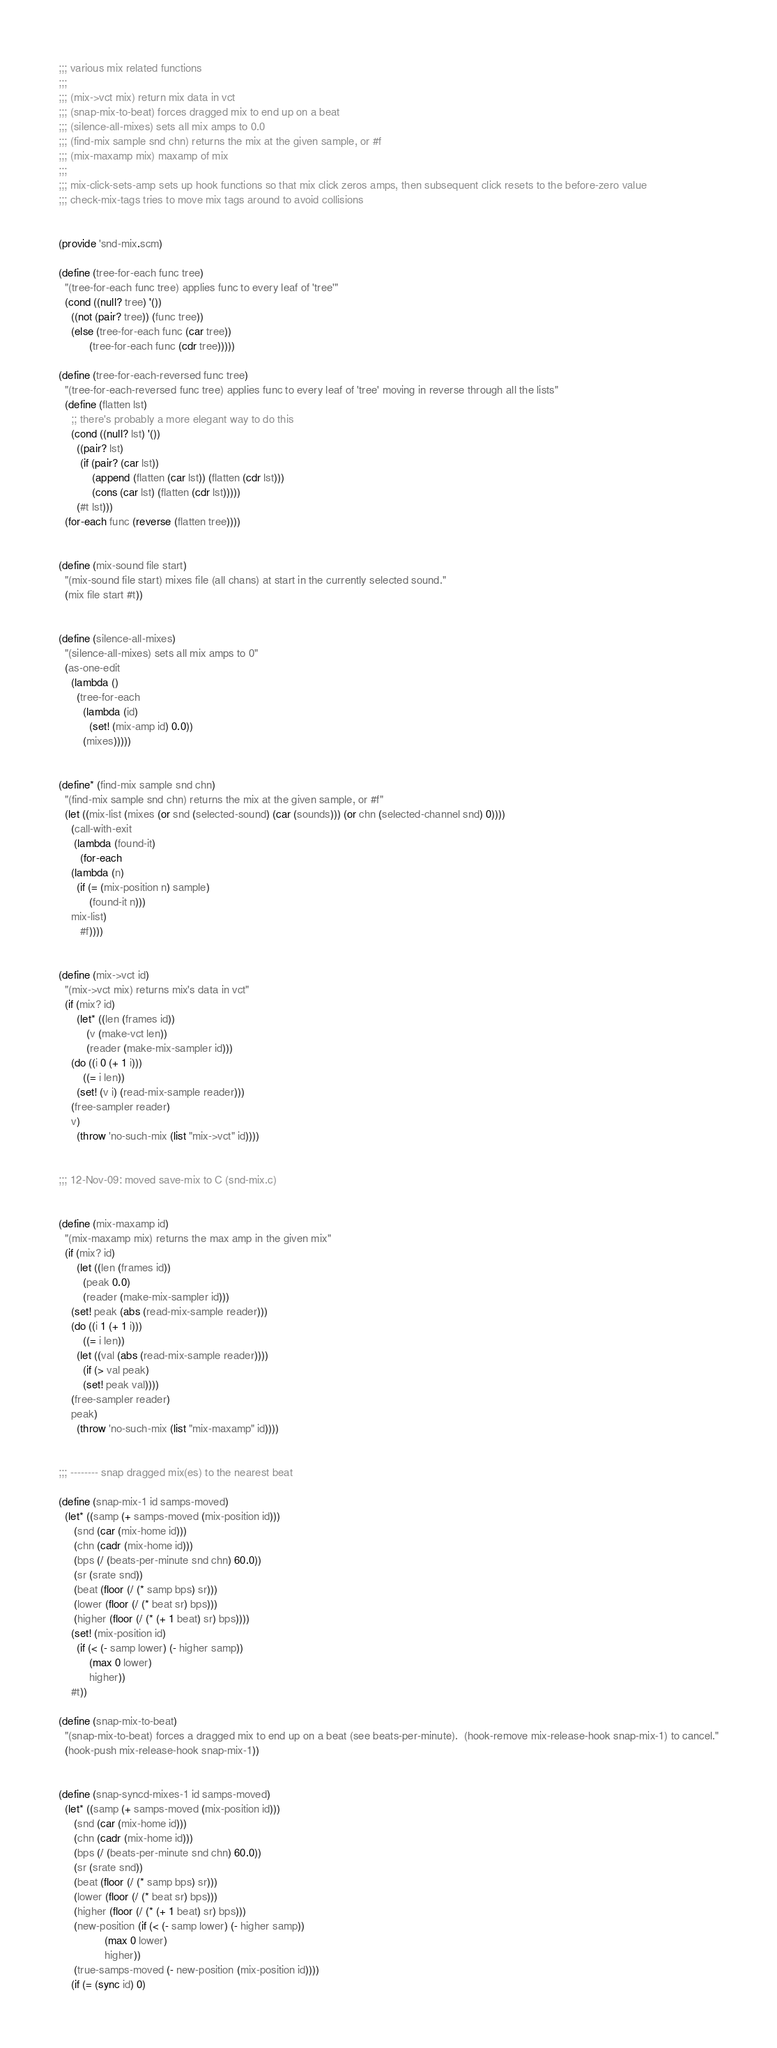Convert code to text. <code><loc_0><loc_0><loc_500><loc_500><_Scheme_>;;; various mix related functions
;;;
;;; (mix->vct mix) return mix data in vct
;;; (snap-mix-to-beat) forces dragged mix to end up on a beat
;;; (silence-all-mixes) sets all mix amps to 0.0
;;; (find-mix sample snd chn) returns the mix at the given sample, or #f
;;; (mix-maxamp mix) maxamp of mix
;;;
;;; mix-click-sets-amp sets up hook functions so that mix click zeros amps, then subsequent click resets to the before-zero value
;;; check-mix-tags tries to move mix tags around to avoid collisions


(provide 'snd-mix.scm)

(define (tree-for-each func tree)
  "(tree-for-each func tree) applies func to every leaf of 'tree'"
  (cond ((null? tree) '())
	((not (pair? tree)) (func tree))
	(else (tree-for-each func (car tree))
	      (tree-for-each func (cdr tree)))))

(define (tree-for-each-reversed func tree)
  "(tree-for-each-reversed func tree) applies func to every leaf of 'tree' moving in reverse through all the lists"
  (define (flatten lst)
    ;; there's probably a more elegant way to do this
    (cond ((null? lst) '())
	  ((pair? lst)
	   (if (pair? (car lst))
	       (append (flatten (car lst)) (flatten (cdr lst)))
	       (cons (car lst) (flatten (cdr lst)))))
	  (#t lst)))
  (for-each func (reverse (flatten tree))))


(define (mix-sound file start)
  "(mix-sound file start) mixes file (all chans) at start in the currently selected sound."
  (mix file start #t))


(define (silence-all-mixes)
  "(silence-all-mixes) sets all mix amps to 0"
  (as-one-edit
    (lambda ()
      (tree-for-each
        (lambda (id)
          (set! (mix-amp id) 0.0))
        (mixes)))))


(define* (find-mix sample snd chn)
  "(find-mix sample snd chn) returns the mix at the given sample, or #f"
  (let ((mix-list (mixes (or snd (selected-sound) (car (sounds))) (or chn (selected-channel snd) 0))))
    (call-with-exit
     (lambda (found-it)
       (for-each
	(lambda (n)
	  (if (= (mix-position n) sample)
	      (found-it n)))
	mix-list)
       #f))))


(define (mix->vct id)
  "(mix->vct mix) returns mix's data in vct"
  (if (mix? id)
      (let* ((len (frames id))
	     (v (make-vct len))
	     (reader (make-mix-sampler id)))
	(do ((i 0 (+ 1 i)))
	    ((= i len))
	  (set! (v i) (read-mix-sample reader)))
	(free-sampler reader)
	v)
      (throw 'no-such-mix (list "mix->vct" id))))


;;; 12-Nov-09: moved save-mix to C (snd-mix.c)


(define (mix-maxamp id)
  "(mix-maxamp mix) returns the max amp in the given mix"
  (if (mix? id)
      (let ((len (frames id))
	    (peak 0.0)
	    (reader (make-mix-sampler id)))
	(set! peak (abs (read-mix-sample reader)))
	(do ((i 1 (+ 1 i)))
	    ((= i len))
	  (let ((val (abs (read-mix-sample reader))))
	    (if (> val peak)
		(set! peak val))))
	(free-sampler reader)
	peak)
      (throw 'no-such-mix (list "mix-maxamp" id))))
	  

;;; -------- snap dragged mix(es) to the nearest beat

(define (snap-mix-1 id samps-moved)
  (let* ((samp (+ samps-moved (mix-position id)))
	 (snd (car (mix-home id)))
	 (chn (cadr (mix-home id)))
	 (bps (/ (beats-per-minute snd chn) 60.0))
	 (sr (srate snd))
	 (beat (floor (/ (* samp bps) sr)))
	 (lower (floor (/ (* beat sr) bps)))
	 (higher (floor (/ (* (+ 1 beat) sr) bps))))
    (set! (mix-position id)
	  (if (< (- samp lower) (- higher samp))
	      (max 0 lower)
	      higher))
    #t))

(define (snap-mix-to-beat)
  "(snap-mix-to-beat) forces a dragged mix to end up on a beat (see beats-per-minute).  (hook-remove mix-release-hook snap-mix-1) to cancel."
  (hook-push mix-release-hook snap-mix-1))


(define (snap-syncd-mixes-1 id samps-moved)
  (let* ((samp (+ samps-moved (mix-position id)))
	 (snd (car (mix-home id)))
	 (chn (cadr (mix-home id)))
	 (bps (/ (beats-per-minute snd chn) 60.0))
	 (sr (srate snd))
	 (beat (floor (/ (* samp bps) sr)))
	 (lower (floor (/ (* beat sr) bps)))
	 (higher (floor (/ (* (+ 1 beat) sr) bps)))
	 (new-position (if (< (- samp lower) (- higher samp))
			   (max 0 lower)
			   higher))
	 (true-samps-moved (- new-position (mix-position id))))
    (if (= (sync id) 0)</code> 